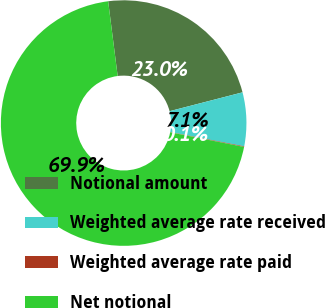Convert chart. <chart><loc_0><loc_0><loc_500><loc_500><pie_chart><fcel>Notional amount<fcel>Weighted average rate received<fcel>Weighted average rate paid<fcel>Net notional<nl><fcel>22.99%<fcel>7.06%<fcel>0.08%<fcel>69.87%<nl></chart> 